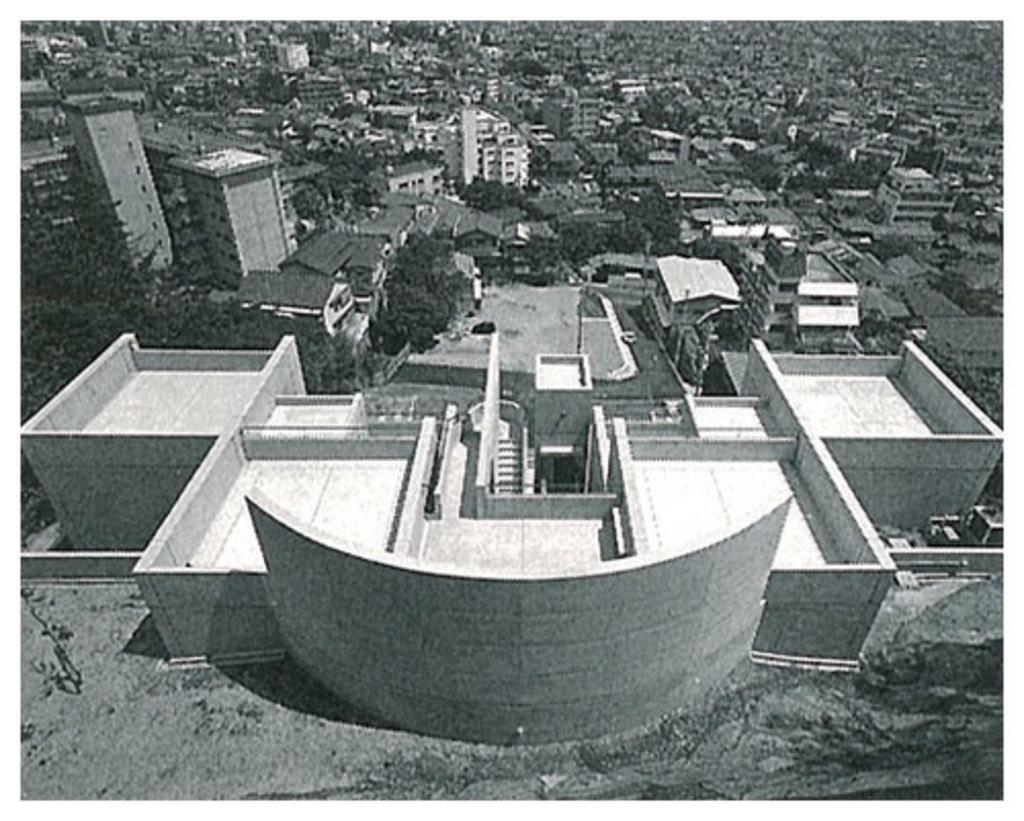What is the main subject of the image? The image shows an aerial view of a large building. Can you describe the surrounding area of the large building? There are houses and other buildings visible near the large building. How many geese are flying over the large building in the image? There are no geese visible in the image. What type of drum is being played in the image? There is no drum present in the image. 